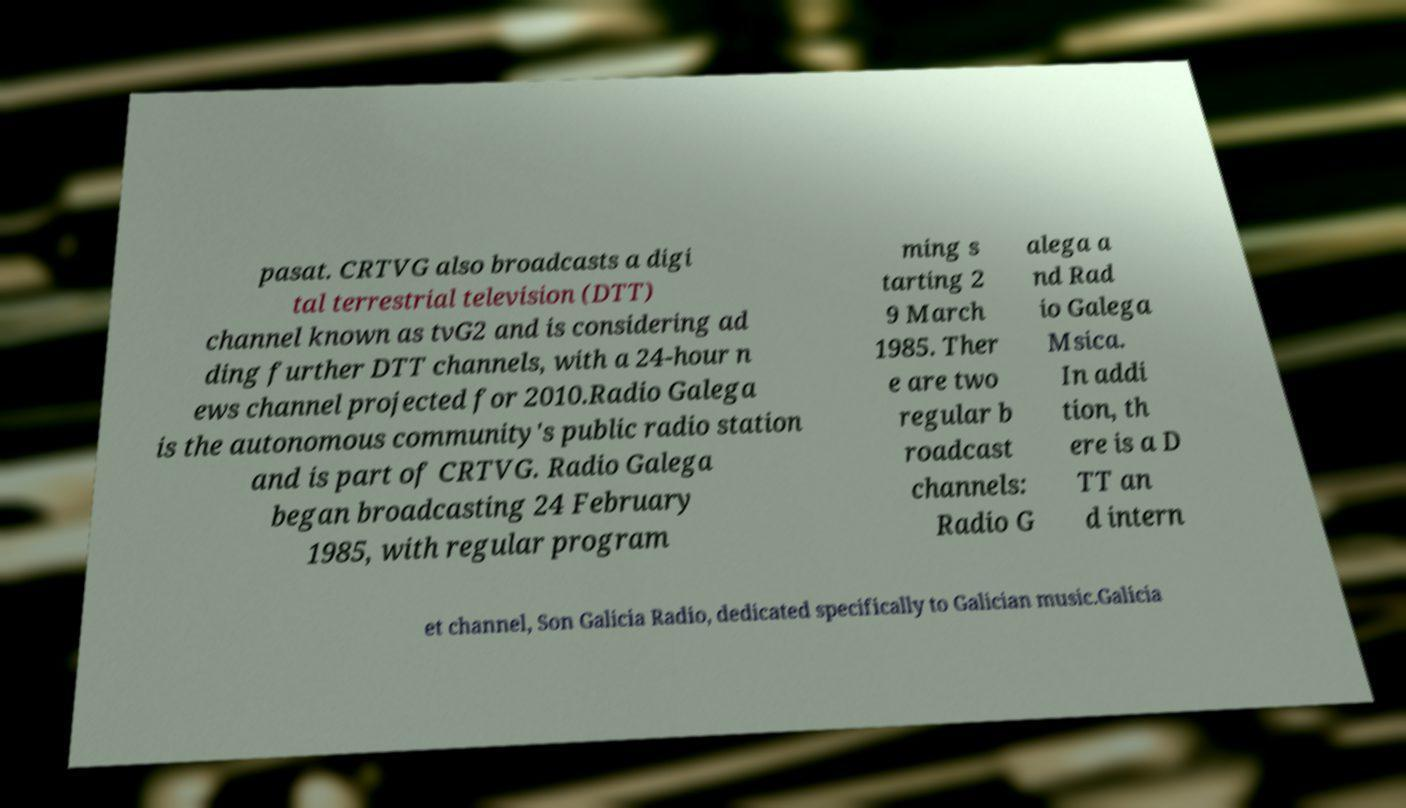Could you extract and type out the text from this image? pasat. CRTVG also broadcasts a digi tal terrestrial television (DTT) channel known as tvG2 and is considering ad ding further DTT channels, with a 24-hour n ews channel projected for 2010.Radio Galega is the autonomous community's public radio station and is part of CRTVG. Radio Galega began broadcasting 24 February 1985, with regular program ming s tarting 2 9 March 1985. Ther e are two regular b roadcast channels: Radio G alega a nd Rad io Galega Msica. In addi tion, th ere is a D TT an d intern et channel, Son Galicia Radio, dedicated specifically to Galician music.Galicia 